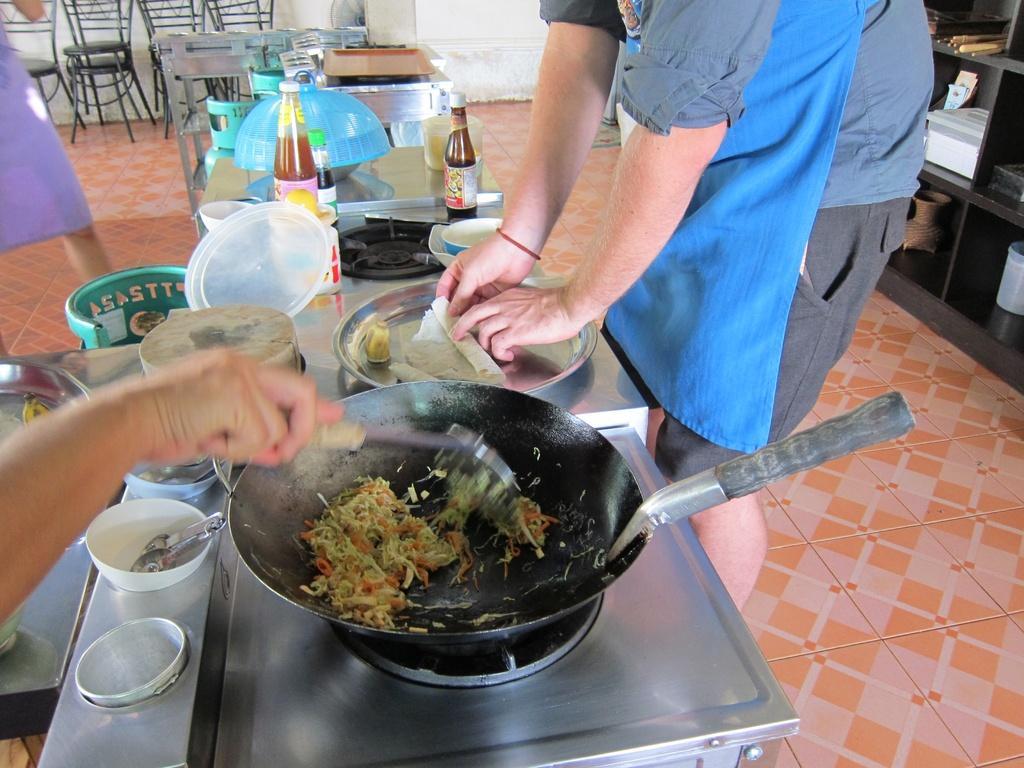Could you give a brief overview of what you see in this image? In this picture I can observe a stove on which frying pan was placed. I can observe two bottles and few things placed on the desk. On the right side there is a person standing. In the background there are some chairs. 